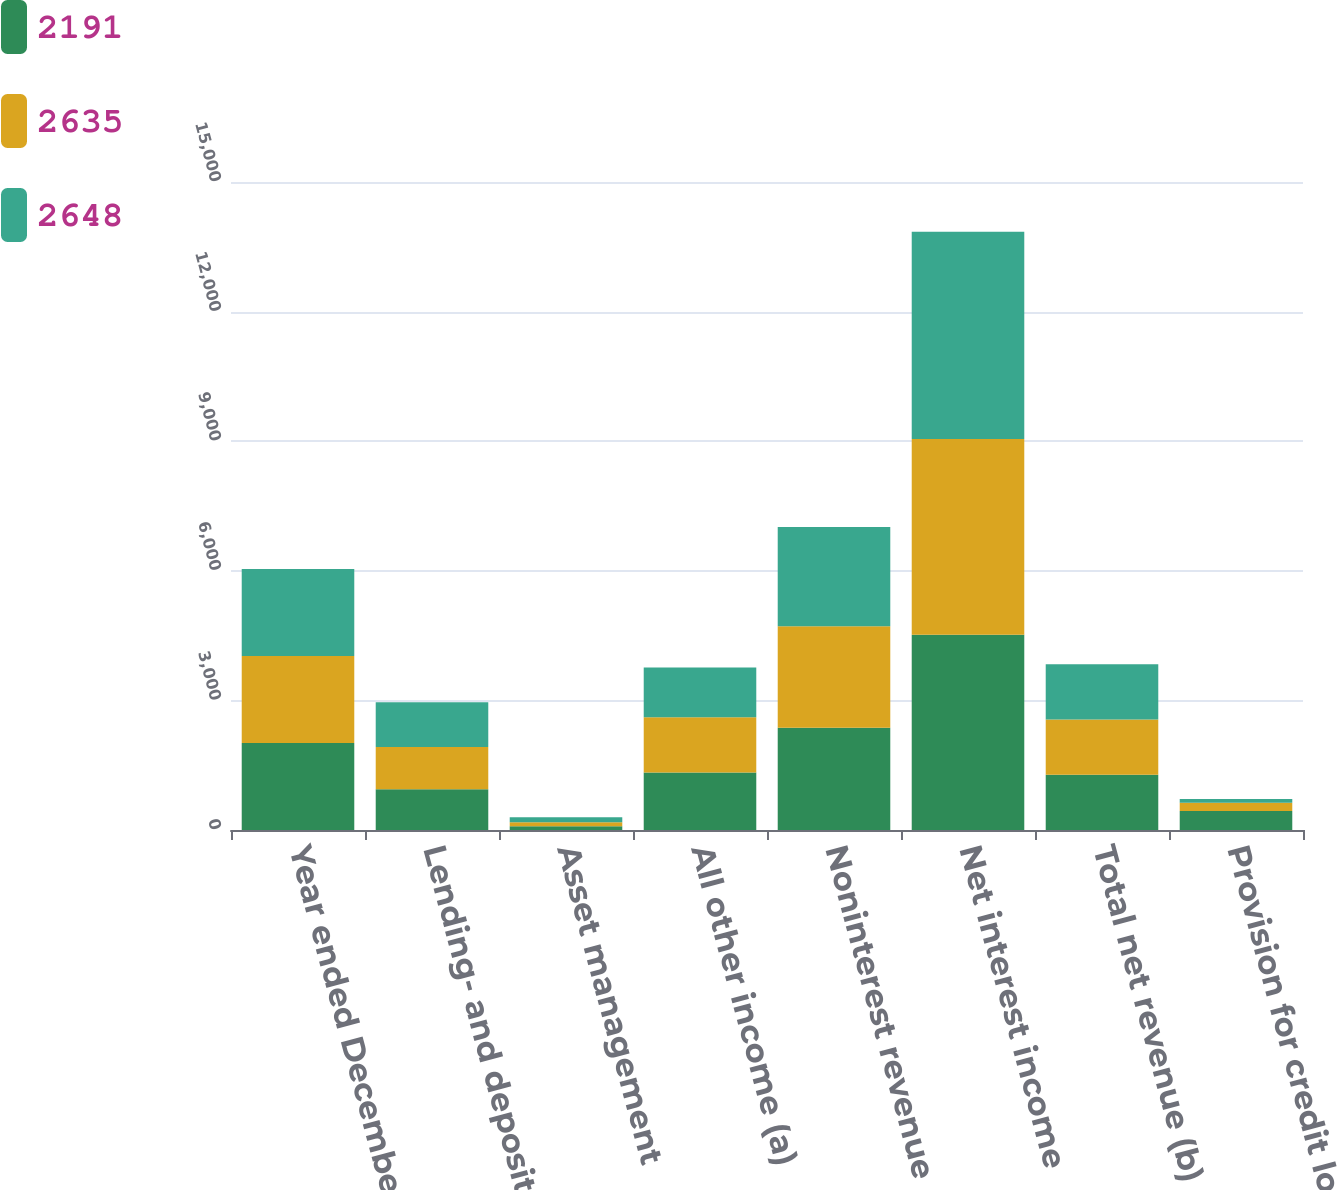<chart> <loc_0><loc_0><loc_500><loc_500><stacked_bar_chart><ecel><fcel>Year ended December 31 (in<fcel>Lending- and deposit-related<fcel>Asset management<fcel>All other income (a)<fcel>Noninterest revenue<fcel>Net interest income<fcel>Total net revenue (b)<fcel>Provision for credit losses<nl><fcel>2191<fcel>2015<fcel>944<fcel>88<fcel>1333<fcel>2365<fcel>4520<fcel>1279<fcel>442<nl><fcel>2635<fcel>2014<fcel>978<fcel>92<fcel>1279<fcel>2349<fcel>4533<fcel>1279<fcel>189<nl><fcel>2648<fcel>2013<fcel>1033<fcel>116<fcel>1149<fcel>2298<fcel>4794<fcel>1279<fcel>85<nl></chart> 